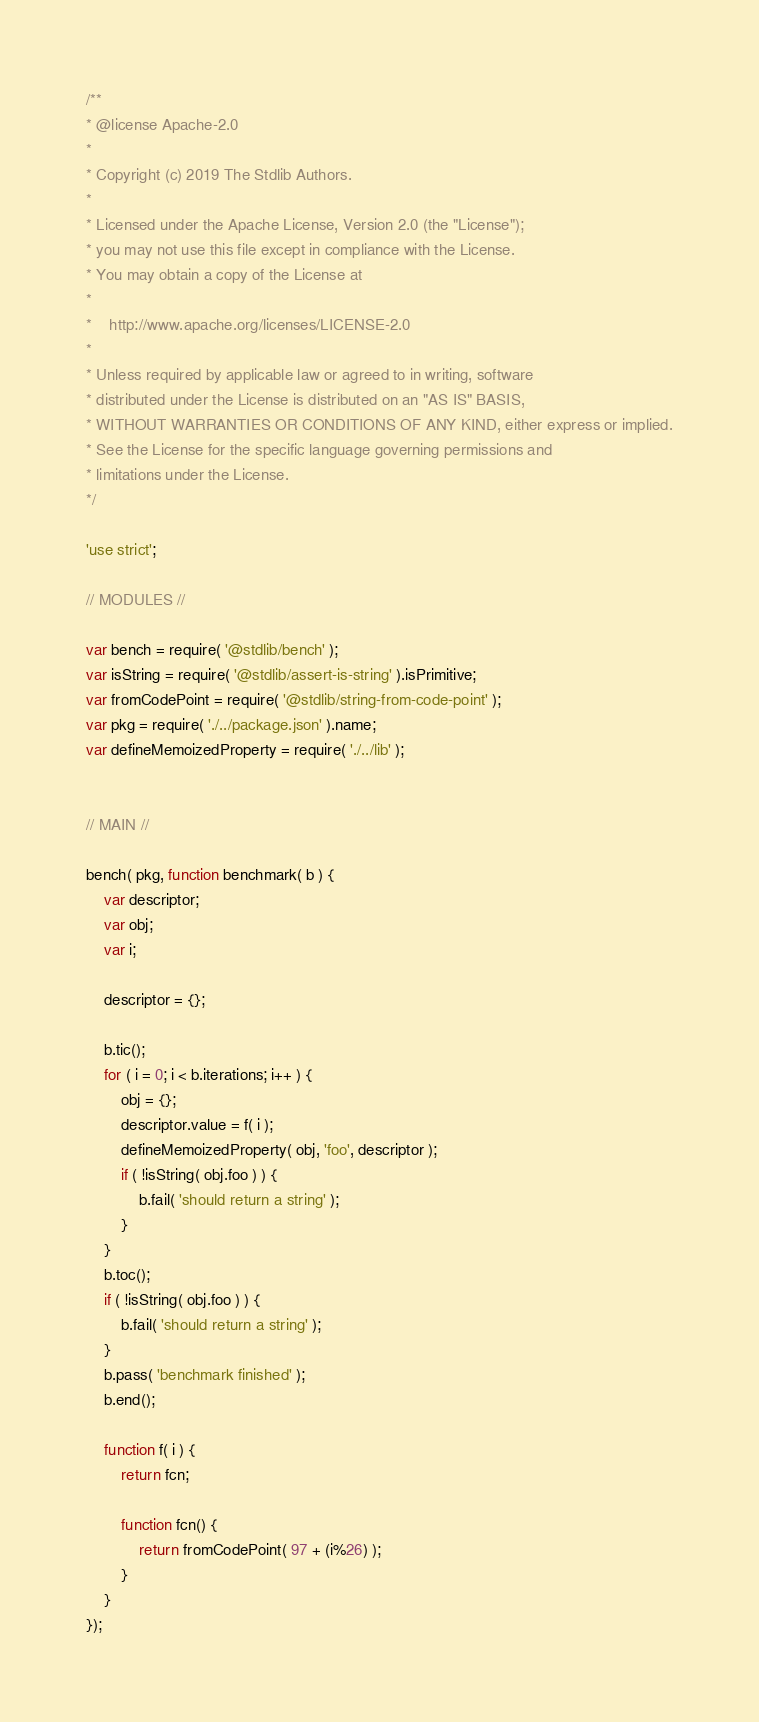<code> <loc_0><loc_0><loc_500><loc_500><_JavaScript_>/**
* @license Apache-2.0
*
* Copyright (c) 2019 The Stdlib Authors.
*
* Licensed under the Apache License, Version 2.0 (the "License");
* you may not use this file except in compliance with the License.
* You may obtain a copy of the License at
*
*    http://www.apache.org/licenses/LICENSE-2.0
*
* Unless required by applicable law or agreed to in writing, software
* distributed under the License is distributed on an "AS IS" BASIS,
* WITHOUT WARRANTIES OR CONDITIONS OF ANY KIND, either express or implied.
* See the License for the specific language governing permissions and
* limitations under the License.
*/

'use strict';

// MODULES //

var bench = require( '@stdlib/bench' );
var isString = require( '@stdlib/assert-is-string' ).isPrimitive;
var fromCodePoint = require( '@stdlib/string-from-code-point' );
var pkg = require( './../package.json' ).name;
var defineMemoizedProperty = require( './../lib' );


// MAIN //

bench( pkg, function benchmark( b ) {
	var descriptor;
	var obj;
	var i;

	descriptor = {};

	b.tic();
	for ( i = 0; i < b.iterations; i++ ) {
		obj = {};
		descriptor.value = f( i );
		defineMemoizedProperty( obj, 'foo', descriptor );
		if ( !isString( obj.foo ) ) {
			b.fail( 'should return a string' );
		}
	}
	b.toc();
	if ( !isString( obj.foo ) ) {
		b.fail( 'should return a string' );
	}
	b.pass( 'benchmark finished' );
	b.end();

	function f( i ) {
		return fcn;

		function fcn() {
			return fromCodePoint( 97 + (i%26) );
		}
	}
});
</code> 